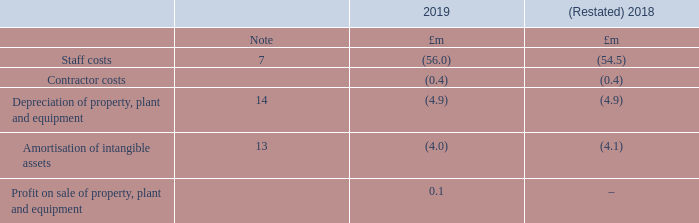6. Operating profit
The Group has identified a number of items which are material due to the significance of their nature and/or amount. These are listed separately here to provide a better understanding of the financial performance of the Group:
Following the application of IFRS 16, depreciation of property, plant and equipment has been restated for the year ended 31 March 2018 (note 2).
Why are some of the items identified by the group considered material? Due to the significance of their nature and/or amount. these are listed separately here to provide a better understanding of the financial performance of the group. What item in the table has been restated for 2018? Following the application of ifrs 16, depreciation of property, plant and equipment has been restated. For which years was Depreciation of property, plant and equipment calculated? 2019, 2018. In which year were staff costs larger? |-56.0|>|-54.5|
Answer: 2019. What was the change in staff costs in 2019 from 2018?
Answer scale should be: million. -56.0-(-54.5)
Answer: -1.5. What was the percentage change in staff costs in 2019 from 2018?
Answer scale should be: percent. (-56.0-(-54.5))/-54.5
Answer: 2.75. 